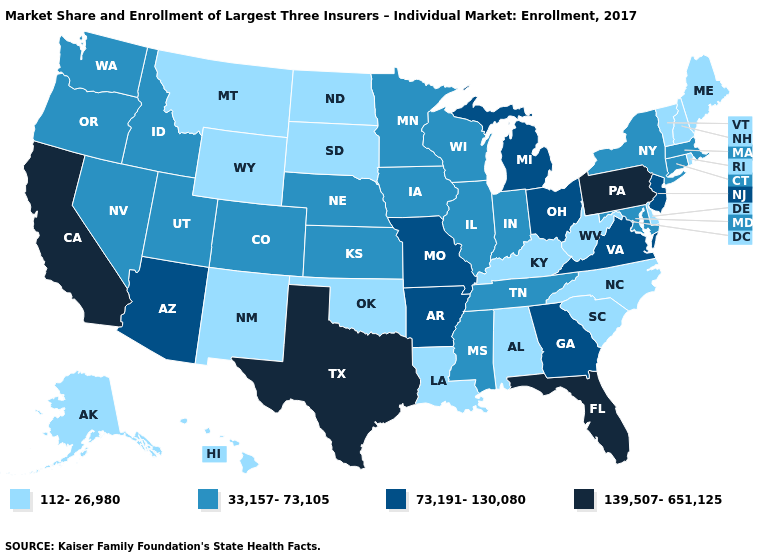Name the states that have a value in the range 112-26,980?
Answer briefly. Alabama, Alaska, Delaware, Hawaii, Kentucky, Louisiana, Maine, Montana, New Hampshire, New Mexico, North Carolina, North Dakota, Oklahoma, Rhode Island, South Carolina, South Dakota, Vermont, West Virginia, Wyoming. Among the states that border Mississippi , which have the lowest value?
Be succinct. Alabama, Louisiana. What is the lowest value in the USA?
Give a very brief answer. 112-26,980. Does Idaho have the lowest value in the USA?
Short answer required. No. Is the legend a continuous bar?
Give a very brief answer. No. What is the value of Wisconsin?
Give a very brief answer. 33,157-73,105. Among the states that border Missouri , which have the highest value?
Concise answer only. Arkansas. Does the map have missing data?
Be succinct. No. What is the value of Maryland?
Quick response, please. 33,157-73,105. Among the states that border South Dakota , does Wyoming have the lowest value?
Short answer required. Yes. Name the states that have a value in the range 139,507-651,125?
Answer briefly. California, Florida, Pennsylvania, Texas. What is the value of Delaware?
Short answer required. 112-26,980. Does Idaho have the lowest value in the West?
Short answer required. No. Which states hav the highest value in the MidWest?
Keep it brief. Michigan, Missouri, Ohio. Does the first symbol in the legend represent the smallest category?
Answer briefly. Yes. 